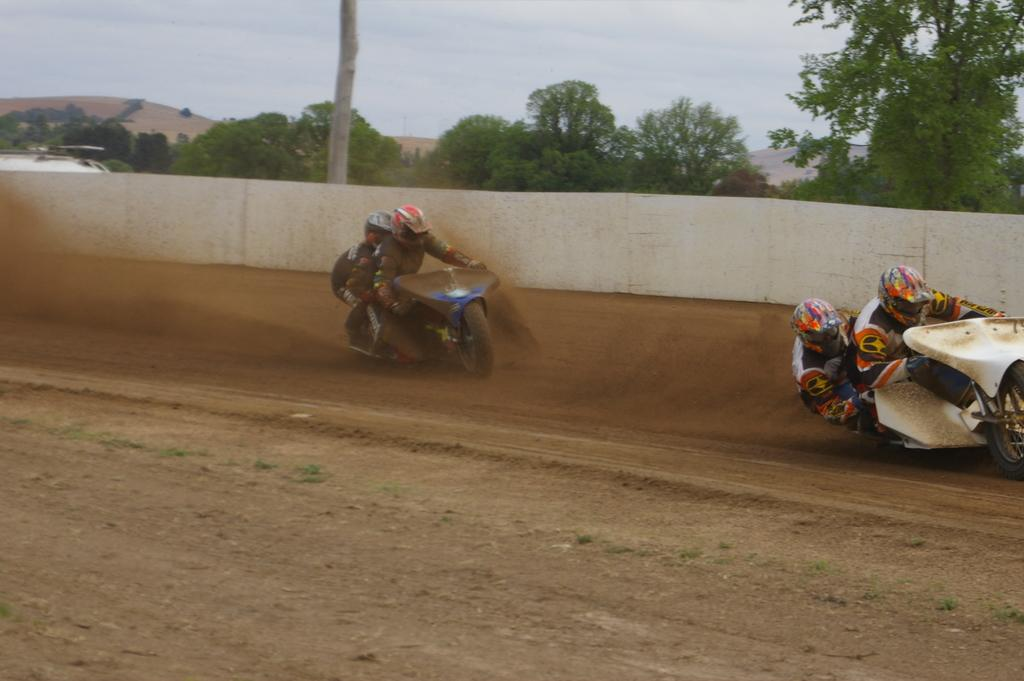How many people are in the image? There are persons in the image. What are the persons wearing on their heads? The persons are wearing helmets. What activity are the persons engaged in? The persons are riding bikes. What is beside the bikes in the image? There is a wall beside which the bikes are being ridden. What type of vegetation can be seen in the image? There are trees visible in the image. What is visible at the top of the image? The sky is visible at the top of the image. What type of children's playroom can be seen in the image? There is no playroom present in the image; it features persons riding bikes near a wall and trees. What scene is depicted in the image? The image depicts persons riding bikes near a wall and trees, with the sky visible at the top. 